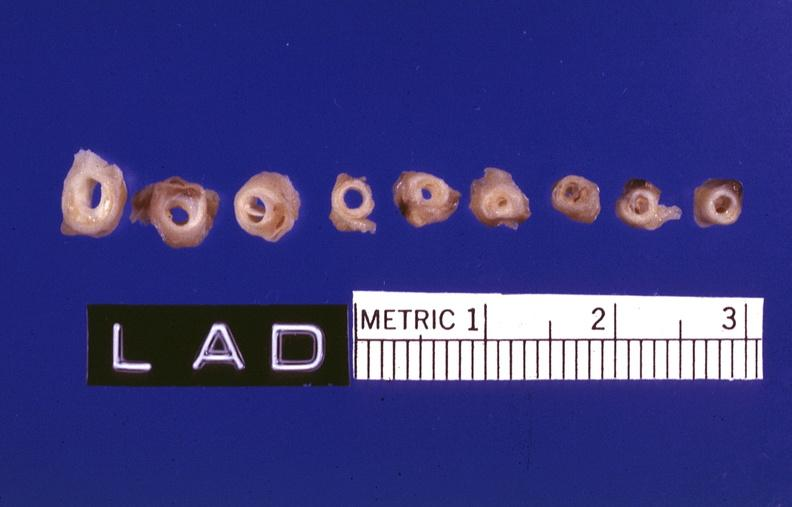does this image show atherosclerosis?
Answer the question using a single word or phrase. Yes 